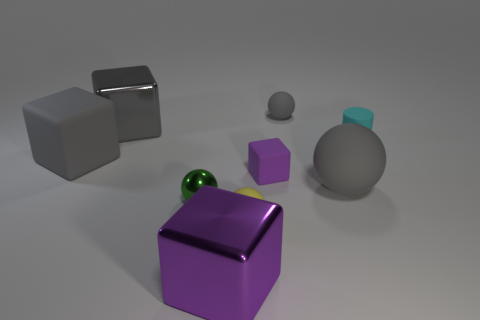Subtract all gray balls. How many were subtracted if there are1gray balls left? 1 Subtract 1 balls. How many balls are left? 3 Add 1 small cyan rubber cylinders. How many objects exist? 10 Subtract all cylinders. How many objects are left? 8 Add 3 big red matte balls. How many big red matte balls exist? 3 Subtract 0 yellow cubes. How many objects are left? 9 Subtract all large shiny cylinders. Subtract all small metallic balls. How many objects are left? 8 Add 5 big shiny cubes. How many big shiny cubes are left? 7 